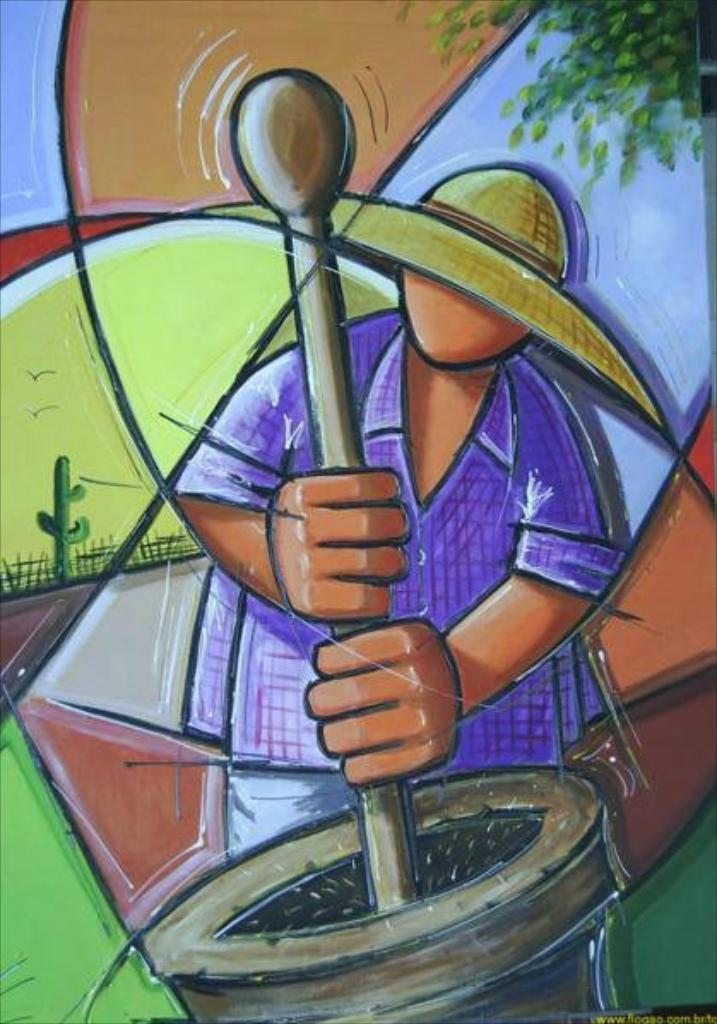What type of artwork is depicted in the image? The image is a painting. Can you describe the person in the painting? There is a person in the painting, and he is holding a stick in his hand. What is the stick doing in the painting? The stick is in a bowl in the painting. What can be seen in the background of the painting? There is a cactus plant, birds, and a tree in the background of the painting. What type of oven can be seen in the painting? There is no oven present in the painting. What material is the tin used for in the painting? There is no tin present in the painting. 